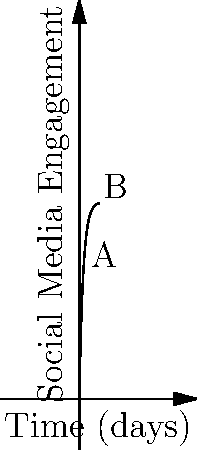The graph represents the social media engagement for a grassroots campaign over time. If point A represents the engagement after 2 days and point B represents the engagement after 8 days, what is the average rate of change in engagement between these two points? To find the average rate of change between two points, we need to use the formula:

$$ \text{Average Rate of Change} = \frac{\text{Change in y}}{\text{Change in x}} = \frac{y_2 - y_1}{x_2 - x_1} $$

Let's follow these steps:

1) First, we need to find the y-values (engagement levels) for points A and B.
   The function describing the curve is $f(x) = 100(1-e^{-0.5x})$

2) For point A (x = 2):
   $y_1 = f(2) = 100(1-e^{-0.5(2)}) \approx 63.21$

3) For point B (x = 8):
   $y_2 = f(8) = 100(1-e^{-0.5(8)}) \approx 98.17$

4) Now we can calculate the average rate of change:

   $\text{Average Rate of Change} = \frac{98.17 - 63.21}{8 - 2} = \frac{34.96}{6} \approx 5.83$

5) This means the average rate of change in engagement between days 2 and 8 is approximately 5.83 units per day.
Answer: 5.83 units per day 